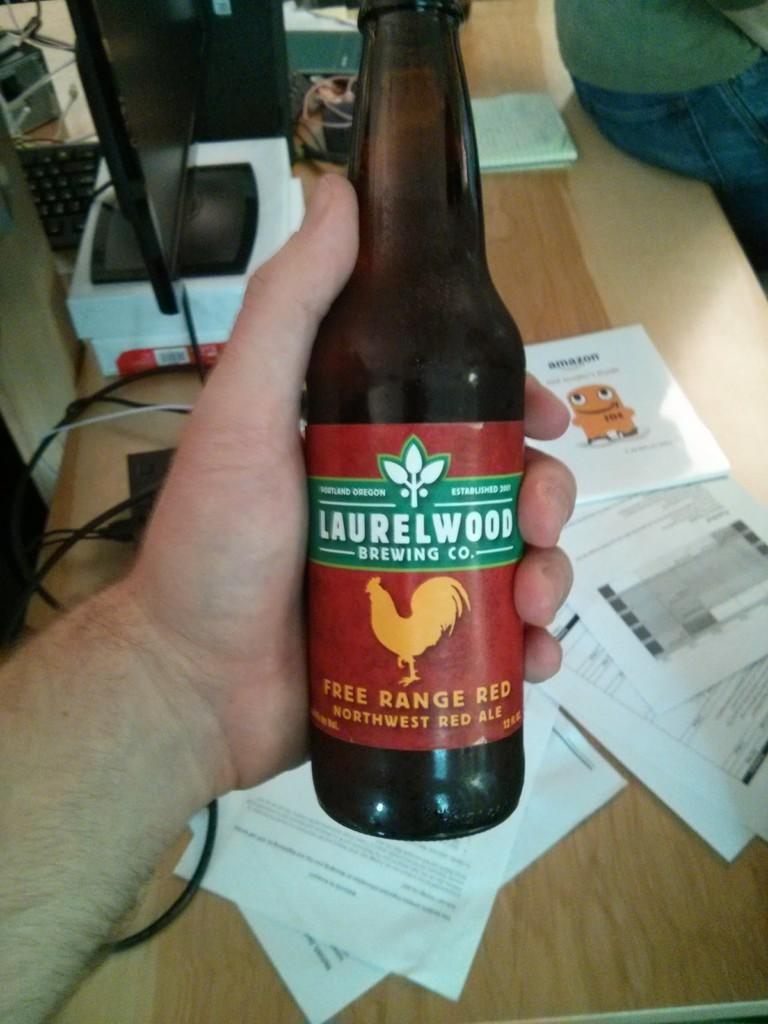Provide a one-sentence caption for the provided image. A man is holding a bottle of beer called Free Range Red from Laurelwood Brewing Co. above a desk scattered with paper. 